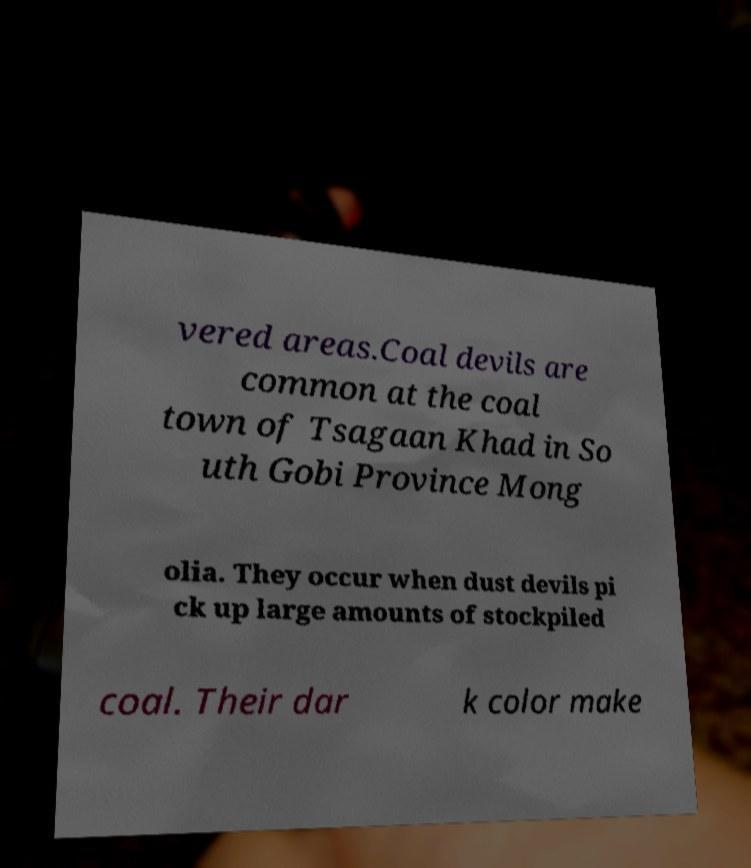Could you extract and type out the text from this image? vered areas.Coal devils are common at the coal town of Tsagaan Khad in So uth Gobi Province Mong olia. They occur when dust devils pi ck up large amounts of stockpiled coal. Their dar k color make 